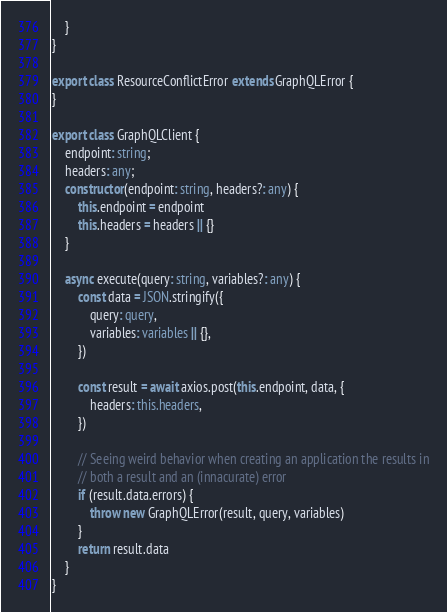<code> <loc_0><loc_0><loc_500><loc_500><_TypeScript_>    }
}

export class ResourceConflictError extends GraphQLError {
}

export class GraphQLClient {
    endpoint: string;
    headers: any;
    constructor(endpoint: string, headers?: any) {
        this.endpoint = endpoint
        this.headers = headers || {}
    }

    async execute(query: string, variables?: any) {
        const data = JSON.stringify({
            query: query,
            variables: variables || {},
        })

        const result = await axios.post(this.endpoint, data, {
            headers: this.headers,
        })

        // Seeing weird behavior when creating an application the results in
        // both a result and an (innacurate) error
        if (result.data.errors) {
            throw new GraphQLError(result, query, variables)
        }
        return result.data
    }
}
</code> 